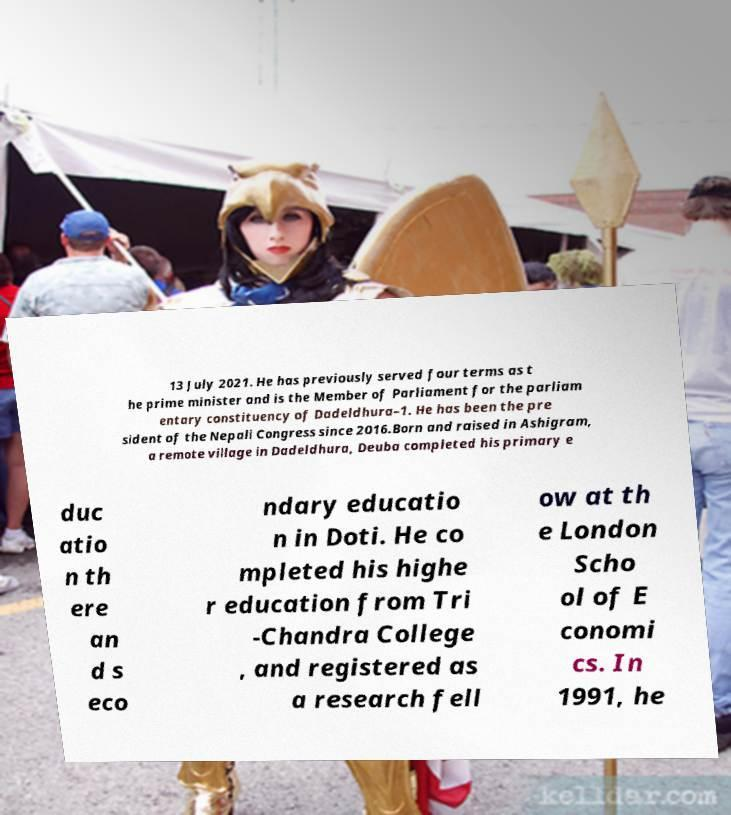Could you assist in decoding the text presented in this image and type it out clearly? 13 July 2021. He has previously served four terms as t he prime minister and is the Member of Parliament for the parliam entary constituency of Dadeldhura–1. He has been the pre sident of the Nepali Congress since 2016.Born and raised in Ashigram, a remote village in Dadeldhura, Deuba completed his primary e duc atio n th ere an d s eco ndary educatio n in Doti. He co mpleted his highe r education from Tri -Chandra College , and registered as a research fell ow at th e London Scho ol of E conomi cs. In 1991, he 